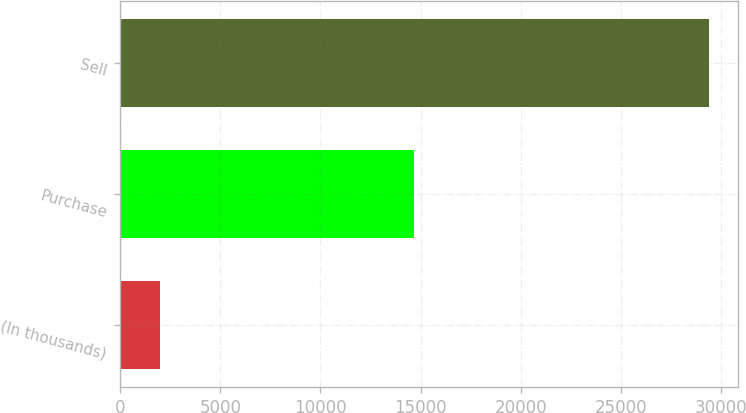<chart> <loc_0><loc_0><loc_500><loc_500><bar_chart><fcel>(In thousands)<fcel>Purchase<fcel>Sell<nl><fcel>2012<fcel>14689<fcel>29362<nl></chart> 